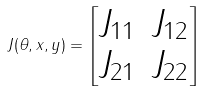<formula> <loc_0><loc_0><loc_500><loc_500>J ( \theta , x , y ) = \begin{bmatrix} J _ { 1 1 } & J _ { 1 2 } \\ J _ { 2 1 } & J _ { 2 2 } \end{bmatrix}</formula> 